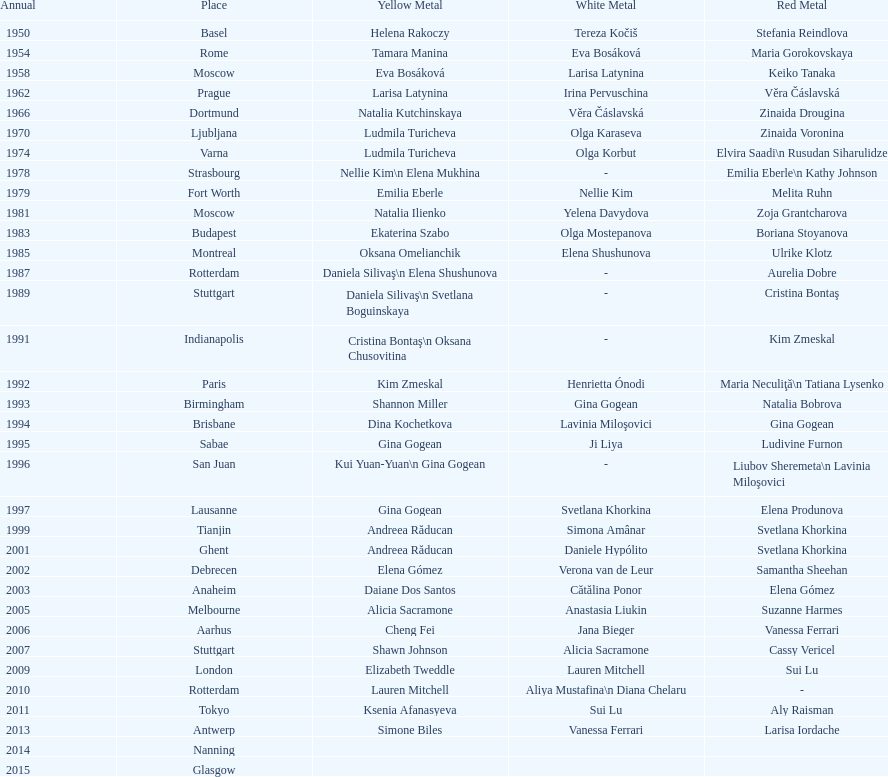Could you parse the entire table? {'header': ['Annual', 'Place', 'Yellow Metal', 'White Metal', 'Red Metal'], 'rows': [['1950', 'Basel', 'Helena Rakoczy', 'Tereza Kočiš', 'Stefania Reindlova'], ['1954', 'Rome', 'Tamara Manina', 'Eva Bosáková', 'Maria Gorokovskaya'], ['1958', 'Moscow', 'Eva Bosáková', 'Larisa Latynina', 'Keiko Tanaka'], ['1962', 'Prague', 'Larisa Latynina', 'Irina Pervuschina', 'Věra Čáslavská'], ['1966', 'Dortmund', 'Natalia Kutchinskaya', 'Věra Čáslavská', 'Zinaida Drougina'], ['1970', 'Ljubljana', 'Ludmila Turicheva', 'Olga Karaseva', 'Zinaida Voronina'], ['1974', 'Varna', 'Ludmila Turicheva', 'Olga Korbut', 'Elvira Saadi\\n Rusudan Siharulidze'], ['1978', 'Strasbourg', 'Nellie Kim\\n Elena Mukhina', '-', 'Emilia Eberle\\n Kathy Johnson'], ['1979', 'Fort Worth', 'Emilia Eberle', 'Nellie Kim', 'Melita Ruhn'], ['1981', 'Moscow', 'Natalia Ilienko', 'Yelena Davydova', 'Zoja Grantcharova'], ['1983', 'Budapest', 'Ekaterina Szabo', 'Olga Mostepanova', 'Boriana Stoyanova'], ['1985', 'Montreal', 'Oksana Omelianchik', 'Elena Shushunova', 'Ulrike Klotz'], ['1987', 'Rotterdam', 'Daniela Silivaş\\n Elena Shushunova', '-', 'Aurelia Dobre'], ['1989', 'Stuttgart', 'Daniela Silivaş\\n Svetlana Boguinskaya', '-', 'Cristina Bontaş'], ['1991', 'Indianapolis', 'Cristina Bontaş\\n Oksana Chusovitina', '-', 'Kim Zmeskal'], ['1992', 'Paris', 'Kim Zmeskal', 'Henrietta Ónodi', 'Maria Neculiţă\\n Tatiana Lysenko'], ['1993', 'Birmingham', 'Shannon Miller', 'Gina Gogean', 'Natalia Bobrova'], ['1994', 'Brisbane', 'Dina Kochetkova', 'Lavinia Miloşovici', 'Gina Gogean'], ['1995', 'Sabae', 'Gina Gogean', 'Ji Liya', 'Ludivine Furnon'], ['1996', 'San Juan', 'Kui Yuan-Yuan\\n Gina Gogean', '-', 'Liubov Sheremeta\\n Lavinia Miloşovici'], ['1997', 'Lausanne', 'Gina Gogean', 'Svetlana Khorkina', 'Elena Produnova'], ['1999', 'Tianjin', 'Andreea Răducan', 'Simona Amânar', 'Svetlana Khorkina'], ['2001', 'Ghent', 'Andreea Răducan', 'Daniele Hypólito', 'Svetlana Khorkina'], ['2002', 'Debrecen', 'Elena Gómez', 'Verona van de Leur', 'Samantha Sheehan'], ['2003', 'Anaheim', 'Daiane Dos Santos', 'Cătălina Ponor', 'Elena Gómez'], ['2005', 'Melbourne', 'Alicia Sacramone', 'Anastasia Liukin', 'Suzanne Harmes'], ['2006', 'Aarhus', 'Cheng Fei', 'Jana Bieger', 'Vanessa Ferrari'], ['2007', 'Stuttgart', 'Shawn Johnson', 'Alicia Sacramone', 'Cassy Vericel'], ['2009', 'London', 'Elizabeth Tweddle', 'Lauren Mitchell', 'Sui Lu'], ['2010', 'Rotterdam', 'Lauren Mitchell', 'Aliya Mustafina\\n Diana Chelaru', '-'], ['2011', 'Tokyo', 'Ksenia Afanasyeva', 'Sui Lu', 'Aly Raisman'], ['2013', 'Antwerp', 'Simone Biles', 'Vanessa Ferrari', 'Larisa Iordache'], ['2014', 'Nanning', '', '', ''], ['2015', 'Glasgow', '', '', '']]} How many times was the location in the united states? 3. 